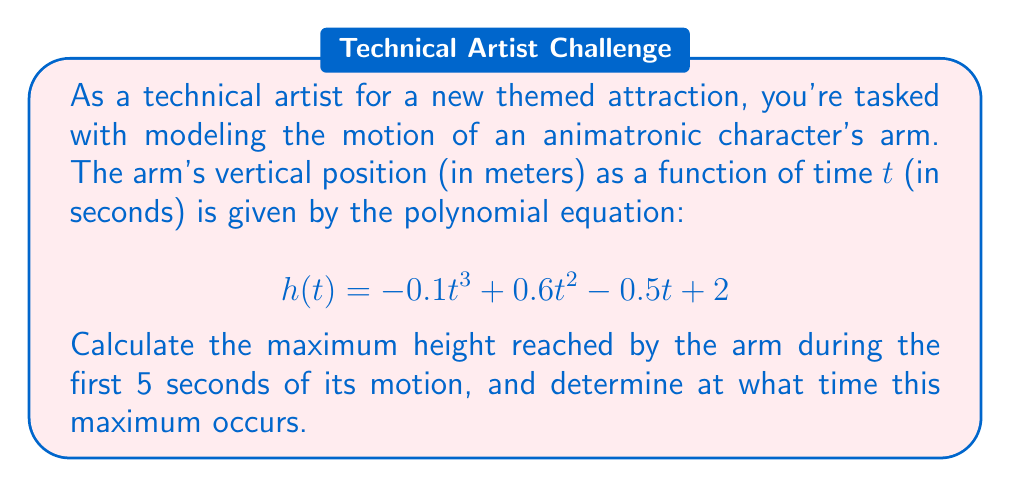Provide a solution to this math problem. To solve this problem, we need to follow these steps:

1. Find the derivative of the height function $h(t)$.
2. Set the derivative equal to zero and solve for t to find potential maximum points.
3. Check the endpoints of the interval [0, 5] as potential maximum points.
4. Evaluate the height function at all potential maximum points to determine the highest point.

Step 1: Find the derivative
The derivative of $h(t)$ is:
$$h'(t) = -0.3t^2 + 1.2t - 0.5$$

Step 2: Set $h'(t) = 0$ and solve for t
$$-0.3t^2 + 1.2t - 0.5 = 0$$

Using the quadratic formula: $t = \frac{-b \pm \sqrt{b^2 - 4ac}}{2a}$

$$t = \frac{-1.2 \pm \sqrt{1.2^2 - 4(-0.3)(-0.5)}}{2(-0.3)}$$
$$t = \frac{-1.2 \pm \sqrt{1.44 - 0.6}}{-0.6}$$
$$t = \frac{-1.2 \pm \sqrt{0.84}}{-0.6}$$
$$t = \frac{-1.2 \pm 0.9165}{-0.6}$$

This gives us two critical points:
$t_1 = \frac{-1.2 + 0.9165}{-0.6} \approx 0.4725$
$t_2 = \frac{-1.2 - 0.9165}{-0.6} \approx 3.5275$

Step 3: Check endpoints
We also need to consider t = 0 and t = 5 as potential maximum points.

Step 4: Evaluate h(t) at all potential maximum points
$h(0) = 2$
$h(0.4725) \approx 2.2364$
$h(3.5275) \approx 3.1636$
$h(5) = 0.5$

The maximum height occurs at t ≈ 3.5275 seconds, with a height of approximately 3.1636 meters.
Answer: The maximum height reached by the animatronic arm during the first 5 seconds is approximately 3.1636 meters, occurring at t ≈ 3.5275 seconds. 